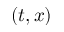Convert formula to latex. <formula><loc_0><loc_0><loc_500><loc_500>( t , x )</formula> 